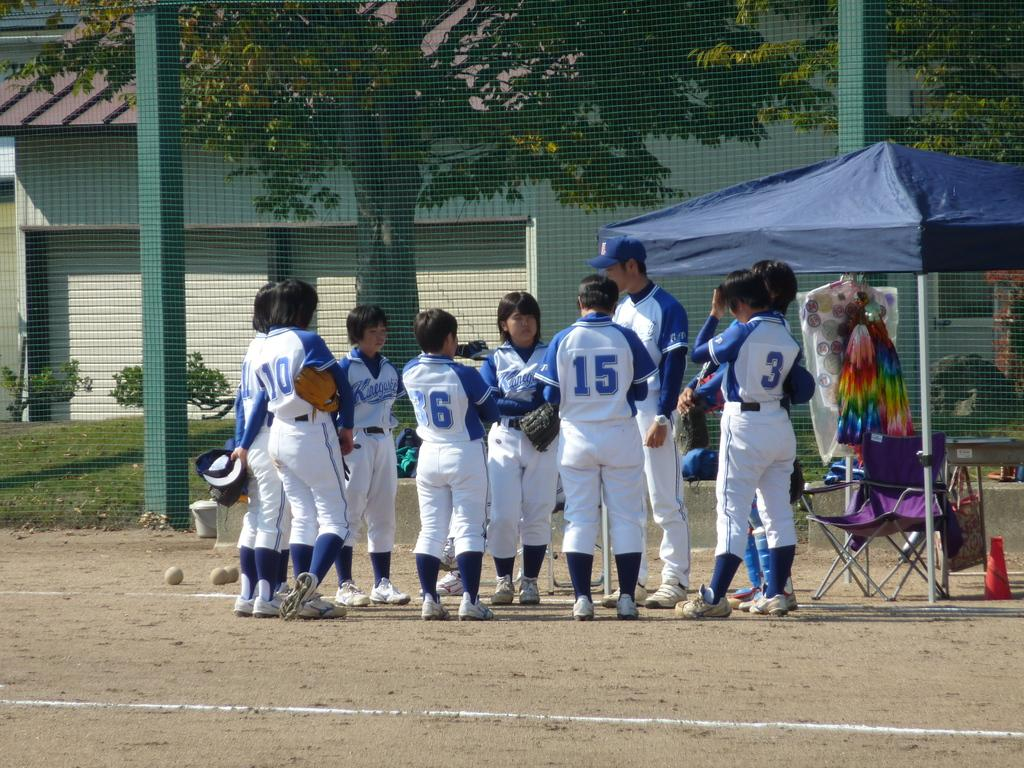<image>
Present a compact description of the photo's key features. A team huddled around its manager including number 15 and number 3. 